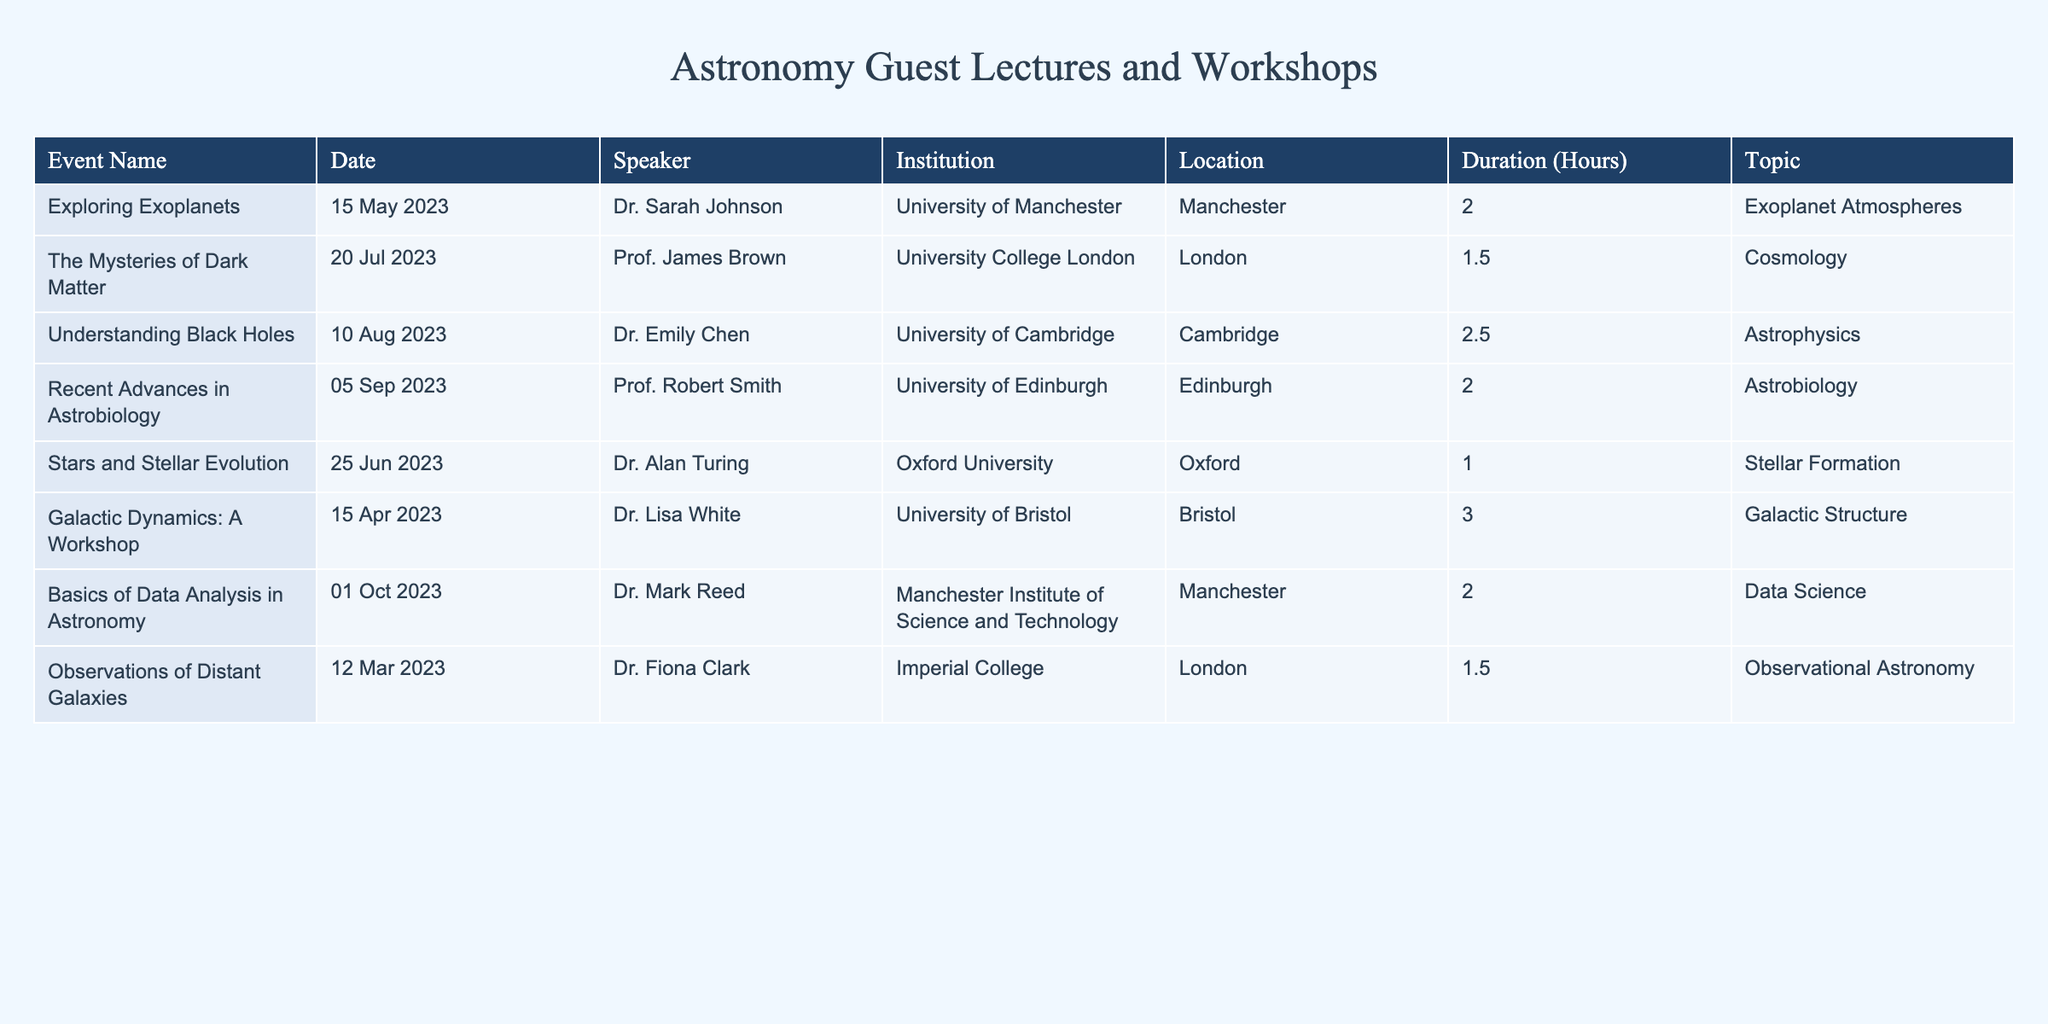What is the longest event duration in the table? The event "Galactic Dynamics: A Workshop" has the longest duration listed at 3 hours. I identified this by comparing the duration values across all events and finding the maximum value.
Answer: 3 hours Who was the speaker for the event on "Understanding Black Holes"? The speaker for the event titled "Understanding Black Holes" is Dr. Emily Chen, which can be found by locating the event in the table and reading the associated speaker name.
Answer: Dr. Emily Chen Which event was held on the 5th of September 2023? The event that took place on the 5th of September 2023 is "Recent Advances in Astrobiology." I located this date in the table and checked which event corresponds to it.
Answer: Recent Advances in Astrobiology Is there an event related to data analysis held in Manchester? Yes, the event titled "Basics of Data Analysis in Astronomy" was held in Manchester. I cross-referenced the location of the events in the table to find this information.
Answer: Yes What is the average duration of all events listed in the table? To find the average duration, I summed the durations: (2 + 1.5 + 2.5 + 2 + 1 + 3 + 2 + 1.5) = 15, then divided by the number of events, which is 8. Therefore, the average is 15 / 8 = 1.875 hours.
Answer: 1.875 hours How many events were held in London? There are three events held in London: "The Mysteries of Dark Matter," "Observations of Distant Galaxies," and "Understanding Black Holes". I counted the occurrences of "London" in the location column.
Answer: 3 events Who was the speaker from the University of Cambridge? The speaker from the University of Cambridge is Dr. Emily Chen, associated with the event "Understanding Black Holes." I checked the institution column for matches to identify the corresponding speaker.
Answer: Dr. Emily Chen What is the total number of institutions represented in the events? There are six distinct institutions represented in the table, namely University of Manchester, University College London, University of Cambridge, University of Edinburgh, Oxford University, and Imperial College. I listed the institutions, removing duplicates to arrive at this total.
Answer: 6 institutions Which topic had the most events based on the table? The topic "Astrophysics" has the most events, specifically "Understanding Black Holes," which can be confirmed by analyzing the topic column and counting occurrences.
Answer: Astrophysics 